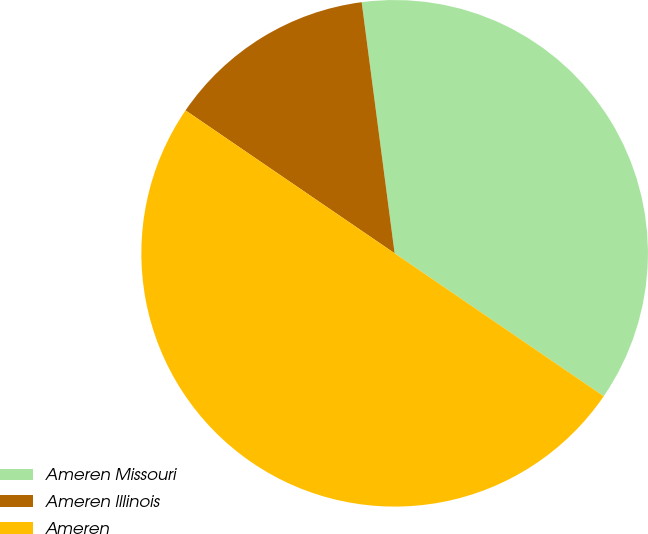<chart> <loc_0><loc_0><loc_500><loc_500><pie_chart><fcel>Ameren Missouri<fcel>Ameren Illinois<fcel>Ameren<nl><fcel>36.62%<fcel>13.38%<fcel>50.0%<nl></chart> 